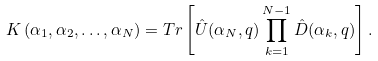Convert formula to latex. <formula><loc_0><loc_0><loc_500><loc_500>K \left ( \alpha _ { 1 } , \alpha _ { 2 } , \dots , \alpha _ { N } \right ) = T r \left [ \hat { U } ( \alpha _ { N } , q ) \prod _ { k = 1 } ^ { N - 1 } \hat { D } ( \alpha _ { k } , q ) \right ] .</formula> 